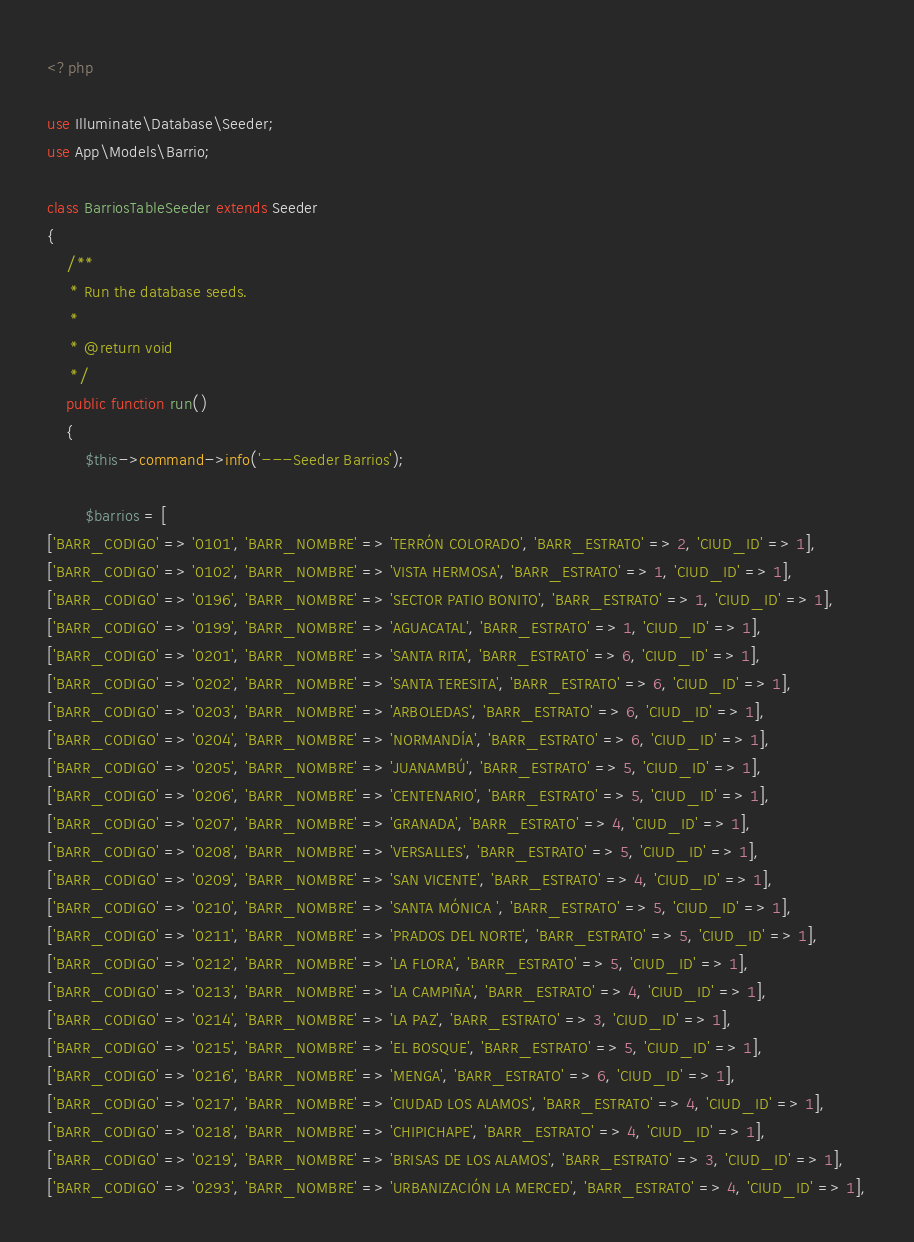Convert code to text. <code><loc_0><loc_0><loc_500><loc_500><_PHP_><?php

use Illuminate\Database\Seeder;
use App\Models\Barrio;

class BarriosTableSeeder extends Seeder
{
	/**
	 * Run the database seeds.
	 *
	 * @return void
	 */
	public function run()
	{
        $this->command->info('---Seeder Barrios');

		$barrios = [
['BARR_CODIGO' => '0101', 'BARR_NOMBRE' => 'TERRÓN COLORADO', 'BARR_ESTRATO' => 2, 'CIUD_ID' => 1],
['BARR_CODIGO' => '0102', 'BARR_NOMBRE' => 'VISTA HERMOSA', 'BARR_ESTRATO' => 1, 'CIUD_ID' => 1],
['BARR_CODIGO' => '0196', 'BARR_NOMBRE' => 'SECTOR PATIO BONITO', 'BARR_ESTRATO' => 1, 'CIUD_ID' => 1],
['BARR_CODIGO' => '0199', 'BARR_NOMBRE' => 'AGUACATAL', 'BARR_ESTRATO' => 1, 'CIUD_ID' => 1],
['BARR_CODIGO' => '0201', 'BARR_NOMBRE' => 'SANTA RITA', 'BARR_ESTRATO' => 6, 'CIUD_ID' => 1],
['BARR_CODIGO' => '0202', 'BARR_NOMBRE' => 'SANTA TERESITA', 'BARR_ESTRATO' => 6, 'CIUD_ID' => 1],
['BARR_CODIGO' => '0203', 'BARR_NOMBRE' => 'ARBOLEDAS', 'BARR_ESTRATO' => 6, 'CIUD_ID' => 1],
['BARR_CODIGO' => '0204', 'BARR_NOMBRE' => 'NORMANDÍA', 'BARR_ESTRATO' => 6, 'CIUD_ID' => 1],
['BARR_CODIGO' => '0205', 'BARR_NOMBRE' => 'JUANAMBÚ', 'BARR_ESTRATO' => 5, 'CIUD_ID' => 1],
['BARR_CODIGO' => '0206', 'BARR_NOMBRE' => 'CENTENARIO', 'BARR_ESTRATO' => 5, 'CIUD_ID' => 1],
['BARR_CODIGO' => '0207', 'BARR_NOMBRE' => 'GRANADA', 'BARR_ESTRATO' => 4, 'CIUD_ID' => 1],
['BARR_CODIGO' => '0208', 'BARR_NOMBRE' => 'VERSALLES', 'BARR_ESTRATO' => 5, 'CIUD_ID' => 1],
['BARR_CODIGO' => '0209', 'BARR_NOMBRE' => 'SAN VICENTE', 'BARR_ESTRATO' => 4, 'CIUD_ID' => 1],
['BARR_CODIGO' => '0210', 'BARR_NOMBRE' => 'SANTA MÓNICA ', 'BARR_ESTRATO' => 5, 'CIUD_ID' => 1],
['BARR_CODIGO' => '0211', 'BARR_NOMBRE' => 'PRADOS DEL NORTE', 'BARR_ESTRATO' => 5, 'CIUD_ID' => 1],
['BARR_CODIGO' => '0212', 'BARR_NOMBRE' => 'LA FLORA', 'BARR_ESTRATO' => 5, 'CIUD_ID' => 1],
['BARR_CODIGO' => '0213', 'BARR_NOMBRE' => 'LA CAMPIÑA', 'BARR_ESTRATO' => 4, 'CIUD_ID' => 1],
['BARR_CODIGO' => '0214', 'BARR_NOMBRE' => 'LA PAZ', 'BARR_ESTRATO' => 3, 'CIUD_ID' => 1],
['BARR_CODIGO' => '0215', 'BARR_NOMBRE' => 'EL BOSQUE', 'BARR_ESTRATO' => 5, 'CIUD_ID' => 1],
['BARR_CODIGO' => '0216', 'BARR_NOMBRE' => 'MENGA', 'BARR_ESTRATO' => 6, 'CIUD_ID' => 1],
['BARR_CODIGO' => '0217', 'BARR_NOMBRE' => 'CIUDAD LOS ALAMOS', 'BARR_ESTRATO' => 4, 'CIUD_ID' => 1],
['BARR_CODIGO' => '0218', 'BARR_NOMBRE' => 'CHIPICHAPE', 'BARR_ESTRATO' => 4, 'CIUD_ID' => 1],
['BARR_CODIGO' => '0219', 'BARR_NOMBRE' => 'BRISAS DE LOS ALAMOS', 'BARR_ESTRATO' => 3, 'CIUD_ID' => 1],
['BARR_CODIGO' => '0293', 'BARR_NOMBRE' => 'URBANIZACIÓN LA MERCED', 'BARR_ESTRATO' => 4, 'CIUD_ID' => 1],</code> 